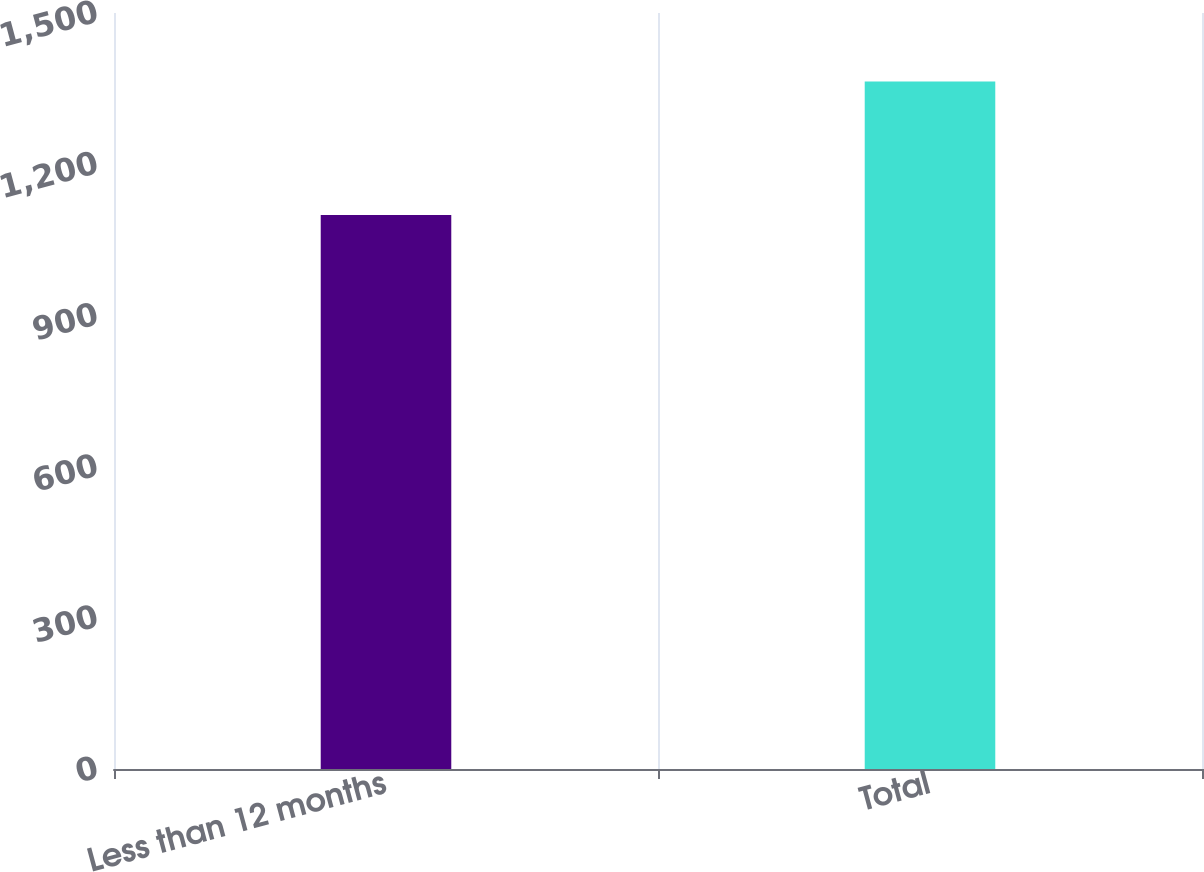<chart> <loc_0><loc_0><loc_500><loc_500><bar_chart><fcel>Less than 12 months<fcel>Total<nl><fcel>1099<fcel>1364<nl></chart> 